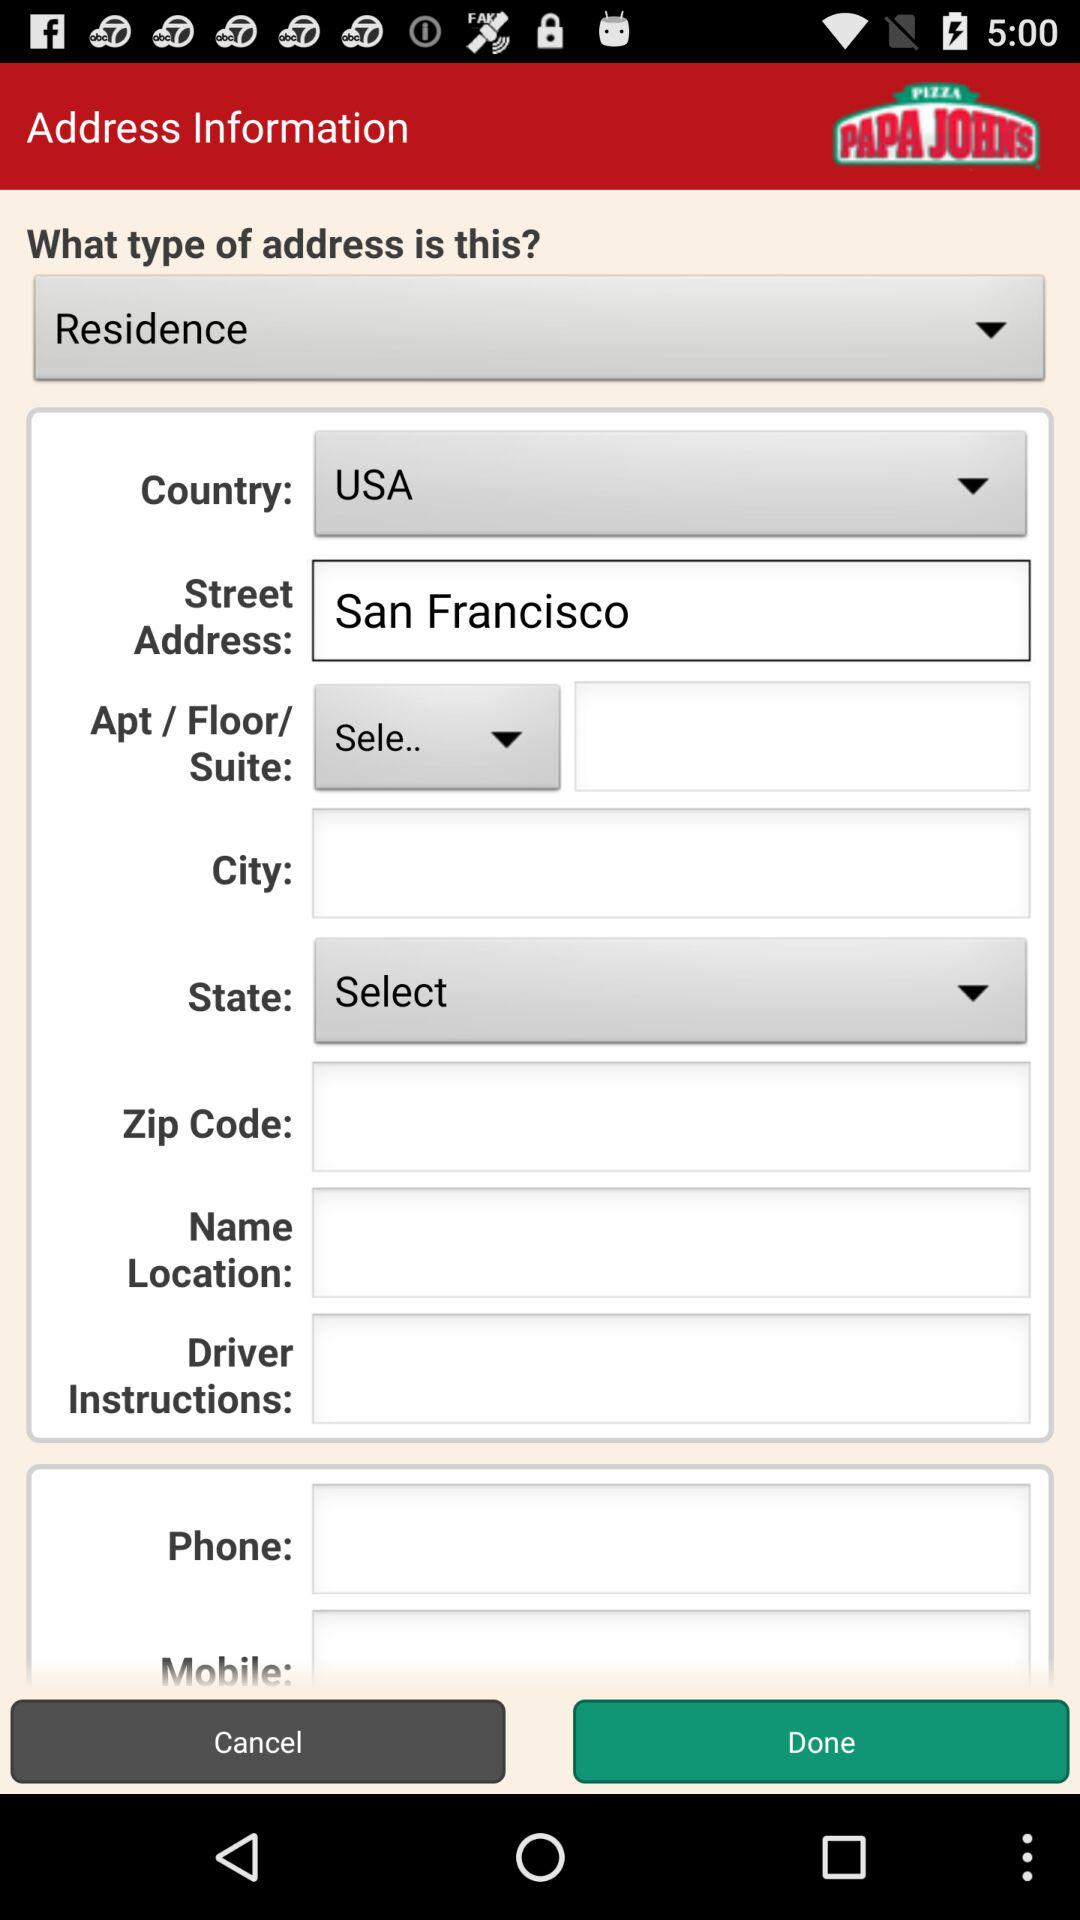What is the street address? The street address is San Francisco. 